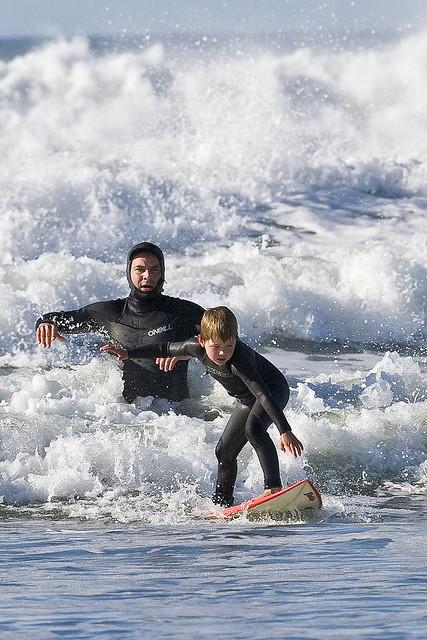Which surfer is more experienced? adult 